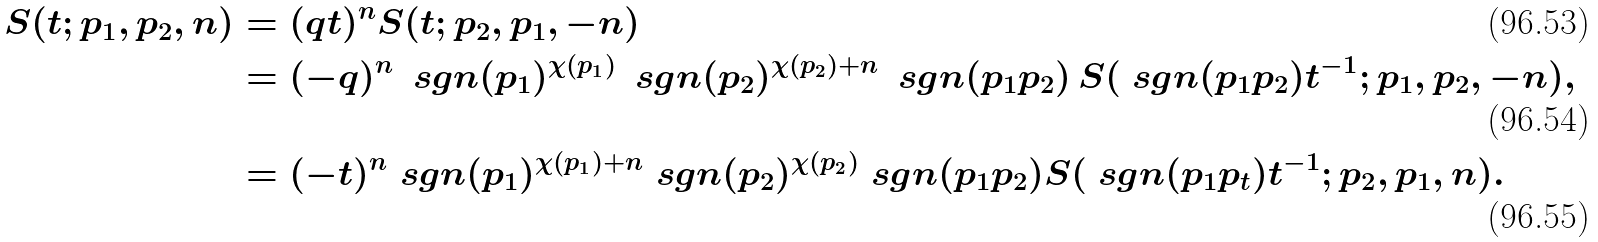Convert formula to latex. <formula><loc_0><loc_0><loc_500><loc_500>S ( t ; p _ { 1 } , p _ { 2 } , n ) & = ( q t ) ^ { n } S ( t ; p _ { 2 } , p _ { 1 } , - n ) \\ & = ( - q ) ^ { n } \, \ s g n ( p _ { 1 } ) ^ { \chi ( p _ { 1 } ) } \, \ s g n ( p _ { 2 } ) ^ { \chi ( p _ { 2 } ) + n } \, \ s g n ( p _ { 1 } p _ { 2 } ) \, S ( \ s g n ( p _ { 1 } p _ { 2 } ) t ^ { - 1 } ; p _ { 1 } , p _ { 2 } , - n ) , \\ & = ( - t ) ^ { n } \ s g n ( p _ { 1 } ) ^ { \chi ( p _ { 1 } ) + n } \ s g n ( p _ { 2 } ) ^ { \chi ( p _ { 2 } ) } \ s g n ( p _ { 1 } p _ { 2 } ) S ( \ s g n ( p _ { 1 } p _ { t } ) t ^ { - 1 } ; p _ { 2 } , p _ { 1 } , n ) .</formula> 